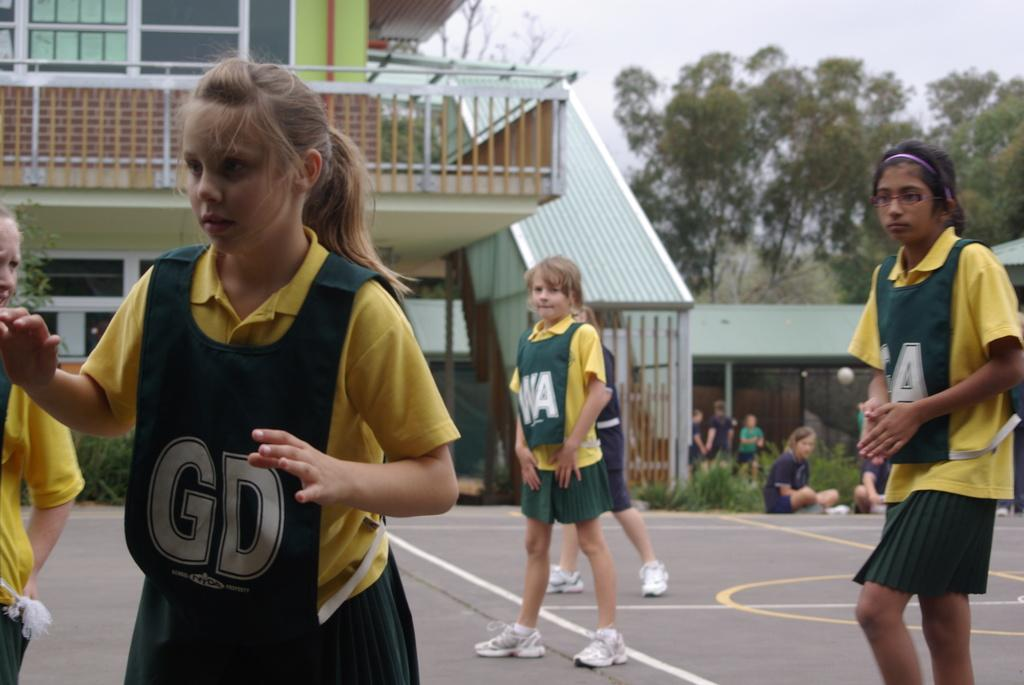What is happening on the ground in the image? There are people on the ground in the image. What can be seen in the distance behind the people? There is a building, plants, trees, and the sky visible in the background of the image. What type of oil is being used by the people in the image? There is no oil present in the image; it features people on the ground and a background with a building, plants, trees, and the sky. 